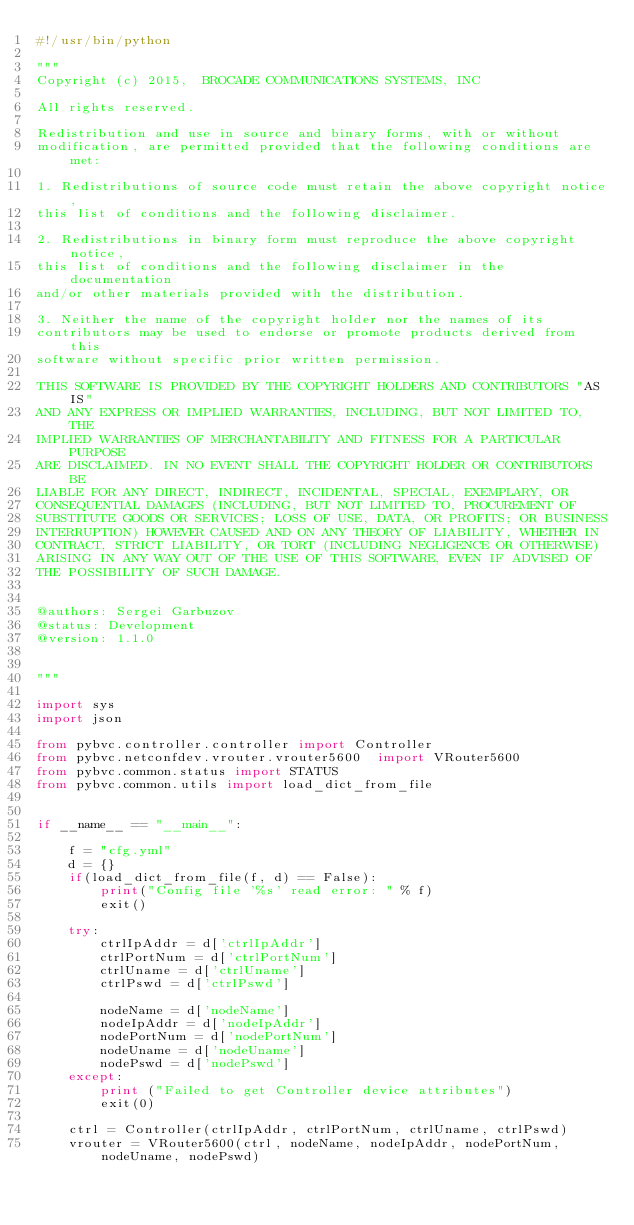Convert code to text. <code><loc_0><loc_0><loc_500><loc_500><_Python_>#!/usr/bin/python

"""
Copyright (c) 2015,  BROCADE COMMUNICATIONS SYSTEMS, INC

All rights reserved.

Redistribution and use in source and binary forms, with or without
modification, are permitted provided that the following conditions are met:

1. Redistributions of source code must retain the above copyright notice,
this list of conditions and the following disclaimer.

2. Redistributions in binary form must reproduce the above copyright notice,
this list of conditions and the following disclaimer in the documentation
and/or other materials provided with the distribution.

3. Neither the name of the copyright holder nor the names of its
contributors may be used to endorse or promote products derived from this
software without specific prior written permission.

THIS SOFTWARE IS PROVIDED BY THE COPYRIGHT HOLDERS AND CONTRIBUTORS "AS IS"
AND ANY EXPRESS OR IMPLIED WARRANTIES, INCLUDING, BUT NOT LIMITED TO, THE
IMPLIED WARRANTIES OF MERCHANTABILITY AND FITNESS FOR A PARTICULAR PURPOSE
ARE DISCLAIMED. IN NO EVENT SHALL THE COPYRIGHT HOLDER OR CONTRIBUTORS BE
LIABLE FOR ANY DIRECT, INDIRECT, INCIDENTAL, SPECIAL, EXEMPLARY, OR
CONSEQUENTIAL DAMAGES (INCLUDING, BUT NOT LIMITED TO, PROCUREMENT OF
SUBSTITUTE GOODS OR SERVICES; LOSS OF USE, DATA, OR PROFITS; OR BUSINESS
INTERRUPTION) HOWEVER CAUSED AND ON ANY THEORY OF LIABILITY, WHETHER IN
CONTRACT, STRICT LIABILITY, OR TORT (INCLUDING NEGLIGENCE OR OTHERWISE)
ARISING IN ANY WAY OUT OF THE USE OF THIS SOFTWARE, EVEN IF ADVISED OF
THE POSSIBILITY OF SUCH DAMAGE.


@authors: Sergei Garbuzov
@status: Development
@version: 1.1.0


"""

import sys
import json

from pybvc.controller.controller import Controller
from pybvc.netconfdev.vrouter.vrouter5600  import VRouter5600
from pybvc.common.status import STATUS
from pybvc.common.utils import load_dict_from_file


if __name__ == "__main__":

    f = "cfg.yml"
    d = {}
    if(load_dict_from_file(f, d) == False):
        print("Config file '%s' read error: " % f)
        exit()

    try:
        ctrlIpAddr = d['ctrlIpAddr']
        ctrlPortNum = d['ctrlPortNum']
        ctrlUname = d['ctrlUname']
        ctrlPswd = d['ctrlPswd']

        nodeName = d['nodeName']
        nodeIpAddr = d['nodeIpAddr']
        nodePortNum = d['nodePortNum']
        nodeUname = d['nodeUname']
        nodePswd = d['nodePswd']
    except:
        print ("Failed to get Controller device attributes")
        exit(0)

    ctrl = Controller(ctrlIpAddr, ctrlPortNum, ctrlUname, ctrlPswd)
    vrouter = VRouter5600(ctrl, nodeName, nodeIpAddr, nodePortNum, nodeUname, nodePswd)</code> 